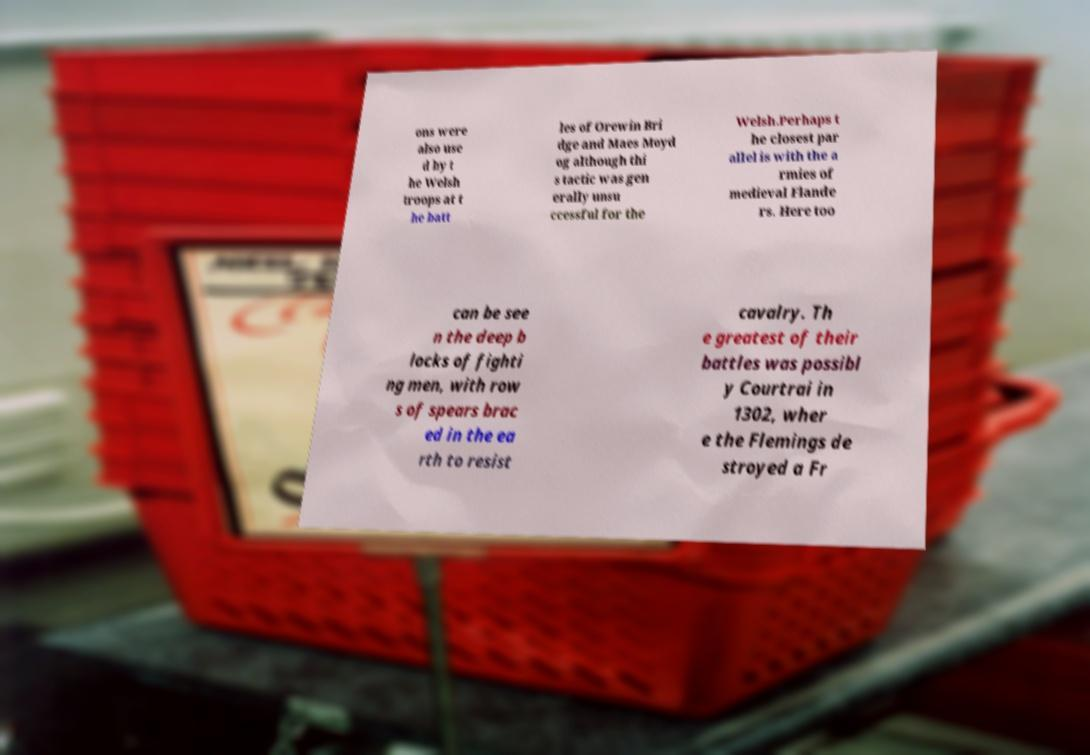For documentation purposes, I need the text within this image transcribed. Could you provide that? ons were also use d by t he Welsh troops at t he batt les of Orewin Bri dge and Maes Moyd og although thi s tactic was gen erally unsu ccessful for the Welsh.Perhaps t he closest par allel is with the a rmies of medieval Flande rs. Here too can be see n the deep b locks of fighti ng men, with row s of spears brac ed in the ea rth to resist cavalry. Th e greatest of their battles was possibl y Courtrai in 1302, wher e the Flemings de stroyed a Fr 